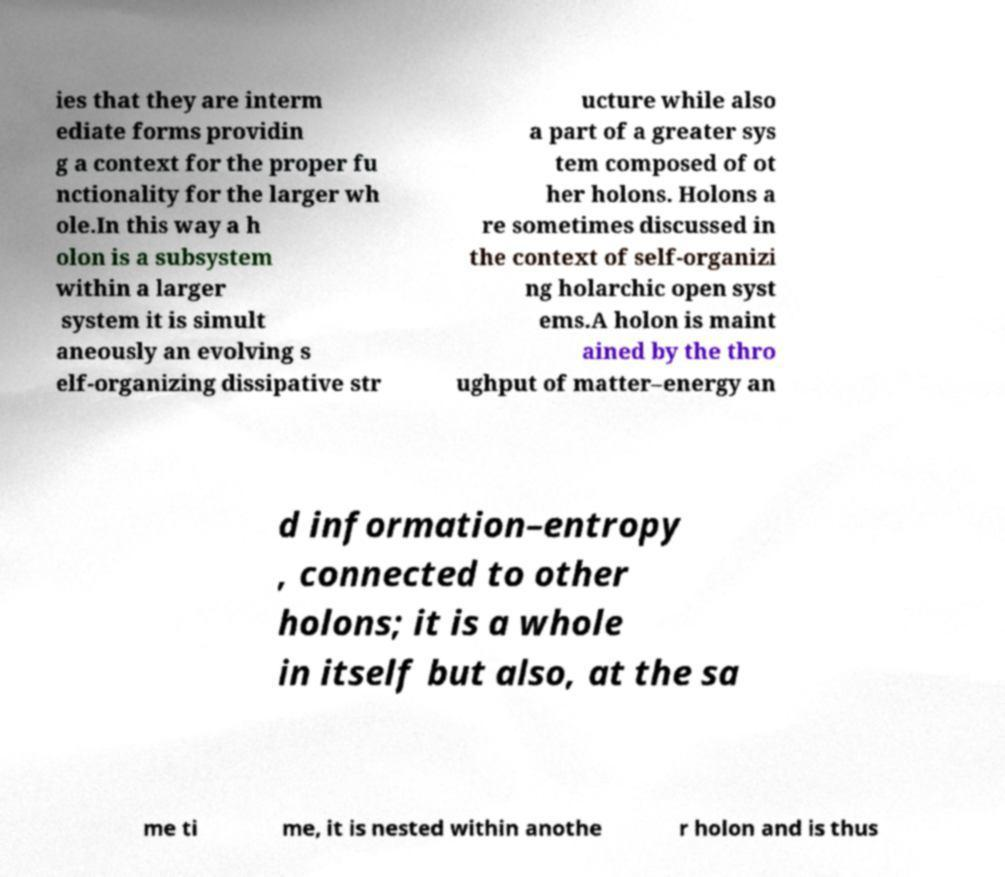There's text embedded in this image that I need extracted. Can you transcribe it verbatim? ies that they are interm ediate forms providin g a context for the proper fu nctionality for the larger wh ole.In this way a h olon is a subsystem within a larger system it is simult aneously an evolving s elf-organizing dissipative str ucture while also a part of a greater sys tem composed of ot her holons. Holons a re sometimes discussed in the context of self-organizi ng holarchic open syst ems.A holon is maint ained by the thro ughput of matter–energy an d information–entropy , connected to other holons; it is a whole in itself but also, at the sa me ti me, it is nested within anothe r holon and is thus 